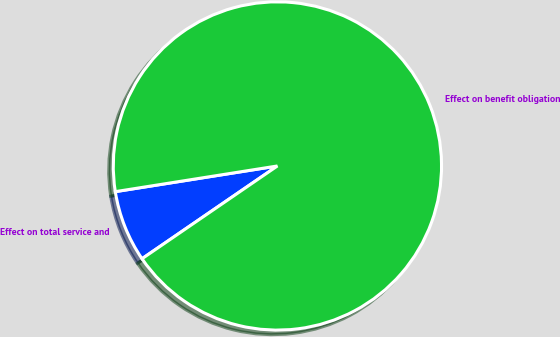Convert chart to OTSL. <chart><loc_0><loc_0><loc_500><loc_500><pie_chart><fcel>Effect on total service and<fcel>Effect on benefit obligation<nl><fcel>7.06%<fcel>92.94%<nl></chart> 